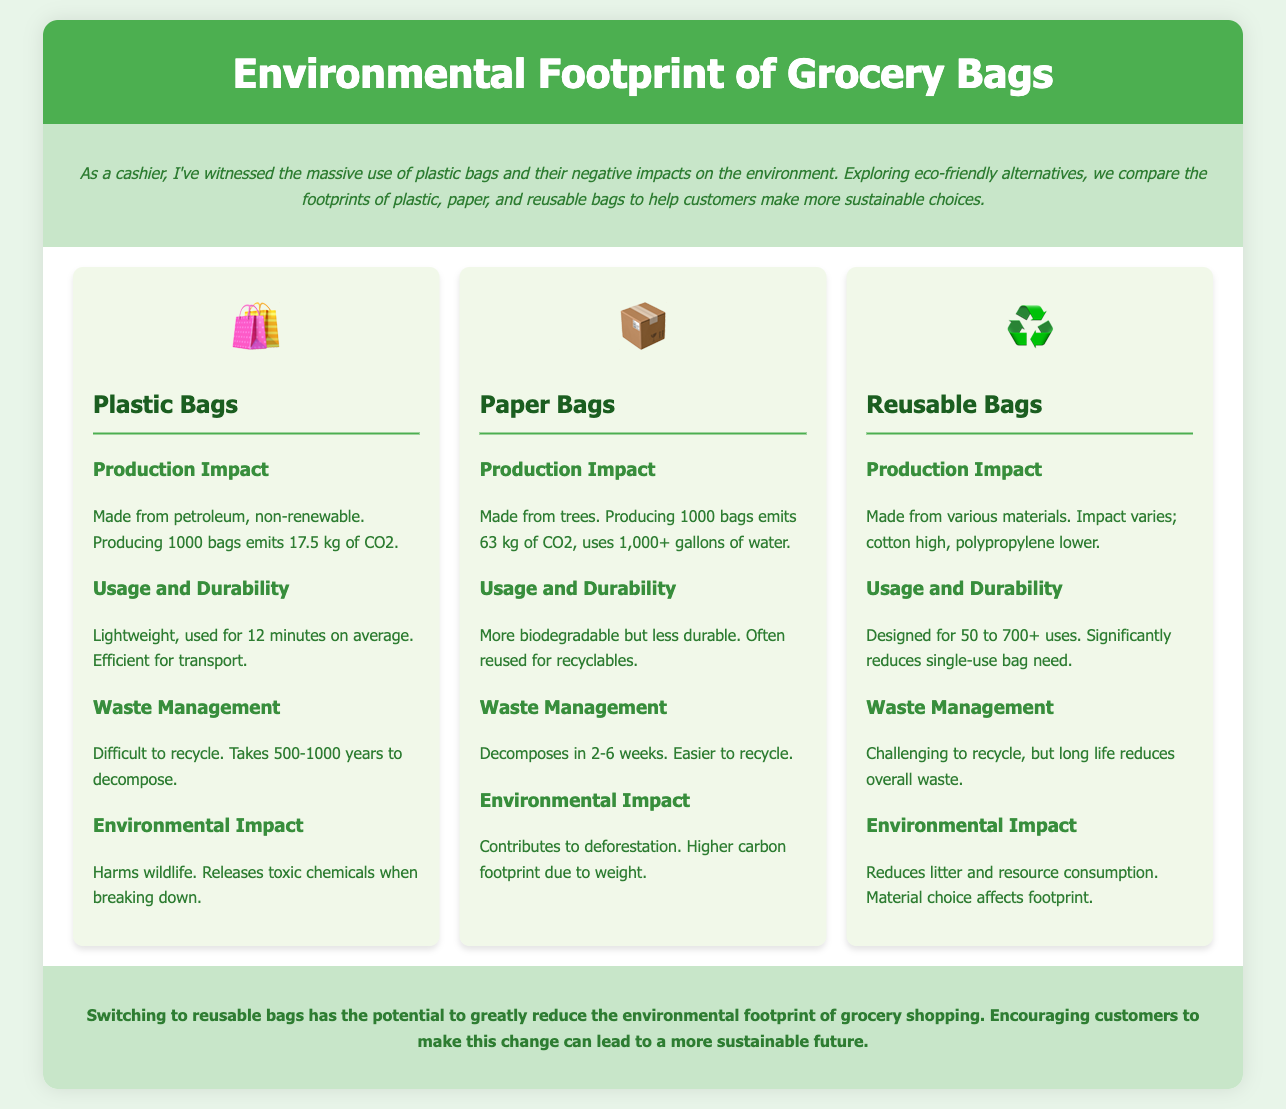what material are plastic bags made from? Plastic bags are made from petroleum, which is a non-renewable resource.
Answer: petroleum how long does it take for a plastic bag to decompose? Plastic bags take 500-1000 years to decompose.
Answer: 500-1000 years how much CO2 is emitted in the production of 1000 paper bags? Producing 1000 paper bags emits 63 kg of CO2.
Answer: 63 kg what is the average usage time for plastic bags? Plastic bags are used for an average of 12 minutes.
Answer: 12 minutes how many uses are reusable bags designed for? Reusable bags are designed for 50 to 700+ uses.
Answer: 50 to 700+ which type of bag is easier to recycle? Paper bags are easier to recycle compared to plastic bags.
Answer: Paper bags what negative impact do paper bags contribute to? Paper bags contribute to deforestation.
Answer: deforestation what is the environmental impact of reusable bags? Reusable bags reduce litter and resource consumption.
Answer: reduces litter and resource consumption which type of bag has the highest CO2 production impact? Paper bags have the highest CO2 production impact at 63 kg for 1000 bags.
Answer: Paper bags how long does it take for paper bags to decompose? Paper bags decompose in 2-6 weeks.
Answer: 2-6 weeks 